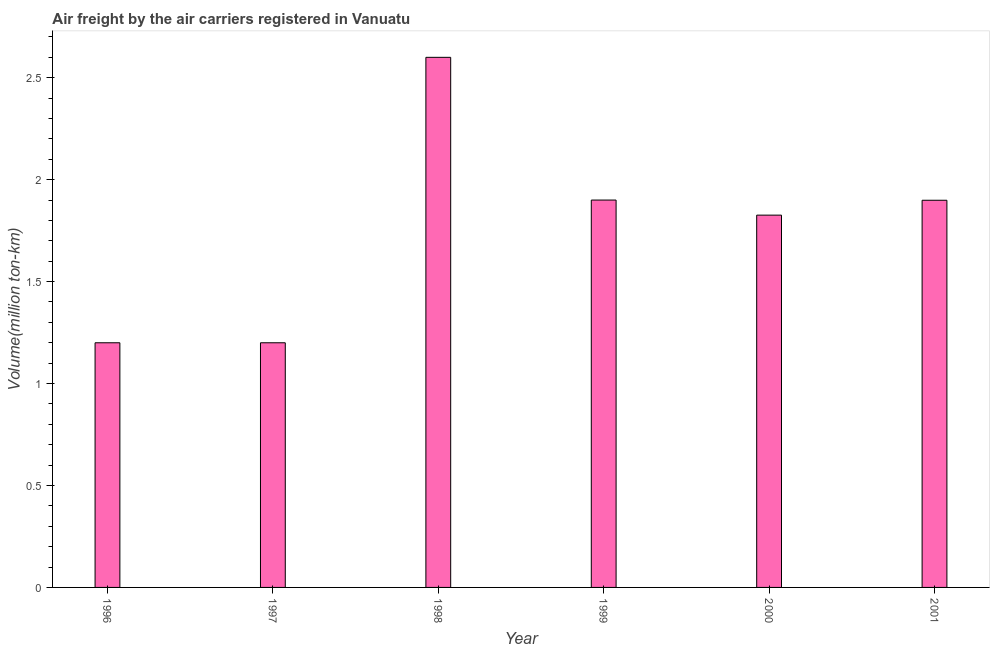Does the graph contain any zero values?
Your answer should be very brief. No. What is the title of the graph?
Offer a terse response. Air freight by the air carriers registered in Vanuatu. What is the label or title of the Y-axis?
Provide a succinct answer. Volume(million ton-km). What is the air freight in 1996?
Provide a short and direct response. 1.2. Across all years, what is the maximum air freight?
Make the answer very short. 2.6. Across all years, what is the minimum air freight?
Make the answer very short. 1.2. In which year was the air freight minimum?
Your answer should be compact. 1996. What is the sum of the air freight?
Make the answer very short. 10.62. What is the difference between the air freight in 1998 and 2001?
Offer a terse response. 0.7. What is the average air freight per year?
Offer a terse response. 1.77. What is the median air freight?
Make the answer very short. 1.86. Do a majority of the years between 1999 and 1998 (inclusive) have air freight greater than 1.5 million ton-km?
Provide a short and direct response. No. What is the ratio of the air freight in 1997 to that in 1998?
Provide a succinct answer. 0.46. Is the difference between the air freight in 1996 and 2001 greater than the difference between any two years?
Ensure brevity in your answer.  No. How many bars are there?
Keep it short and to the point. 6. How many years are there in the graph?
Provide a succinct answer. 6. What is the Volume(million ton-km) of 1996?
Your response must be concise. 1.2. What is the Volume(million ton-km) of 1997?
Your answer should be very brief. 1.2. What is the Volume(million ton-km) of 1998?
Ensure brevity in your answer.  2.6. What is the Volume(million ton-km) of 1999?
Keep it short and to the point. 1.9. What is the Volume(million ton-km) in 2000?
Your response must be concise. 1.83. What is the Volume(million ton-km) in 2001?
Offer a very short reply. 1.9. What is the difference between the Volume(million ton-km) in 1996 and 1997?
Offer a very short reply. 0. What is the difference between the Volume(million ton-km) in 1996 and 1998?
Offer a terse response. -1.4. What is the difference between the Volume(million ton-km) in 1996 and 1999?
Offer a very short reply. -0.7. What is the difference between the Volume(million ton-km) in 1996 and 2000?
Offer a terse response. -0.63. What is the difference between the Volume(million ton-km) in 1996 and 2001?
Provide a succinct answer. -0.7. What is the difference between the Volume(million ton-km) in 1997 and 2000?
Provide a succinct answer. -0.63. What is the difference between the Volume(million ton-km) in 1997 and 2001?
Your answer should be very brief. -0.7. What is the difference between the Volume(million ton-km) in 1998 and 1999?
Ensure brevity in your answer.  0.7. What is the difference between the Volume(million ton-km) in 1998 and 2000?
Your answer should be compact. 0.77. What is the difference between the Volume(million ton-km) in 1998 and 2001?
Make the answer very short. 0.7. What is the difference between the Volume(million ton-km) in 1999 and 2000?
Ensure brevity in your answer.  0.07. What is the difference between the Volume(million ton-km) in 1999 and 2001?
Offer a terse response. 0. What is the difference between the Volume(million ton-km) in 2000 and 2001?
Offer a terse response. -0.07. What is the ratio of the Volume(million ton-km) in 1996 to that in 1997?
Offer a terse response. 1. What is the ratio of the Volume(million ton-km) in 1996 to that in 1998?
Your response must be concise. 0.46. What is the ratio of the Volume(million ton-km) in 1996 to that in 1999?
Ensure brevity in your answer.  0.63. What is the ratio of the Volume(million ton-km) in 1996 to that in 2000?
Your answer should be compact. 0.66. What is the ratio of the Volume(million ton-km) in 1996 to that in 2001?
Provide a short and direct response. 0.63. What is the ratio of the Volume(million ton-km) in 1997 to that in 1998?
Make the answer very short. 0.46. What is the ratio of the Volume(million ton-km) in 1997 to that in 1999?
Give a very brief answer. 0.63. What is the ratio of the Volume(million ton-km) in 1997 to that in 2000?
Your answer should be compact. 0.66. What is the ratio of the Volume(million ton-km) in 1997 to that in 2001?
Make the answer very short. 0.63. What is the ratio of the Volume(million ton-km) in 1998 to that in 1999?
Ensure brevity in your answer.  1.37. What is the ratio of the Volume(million ton-km) in 1998 to that in 2000?
Keep it short and to the point. 1.42. What is the ratio of the Volume(million ton-km) in 1998 to that in 2001?
Make the answer very short. 1.37. What is the ratio of the Volume(million ton-km) in 1999 to that in 2000?
Your answer should be compact. 1.04. 